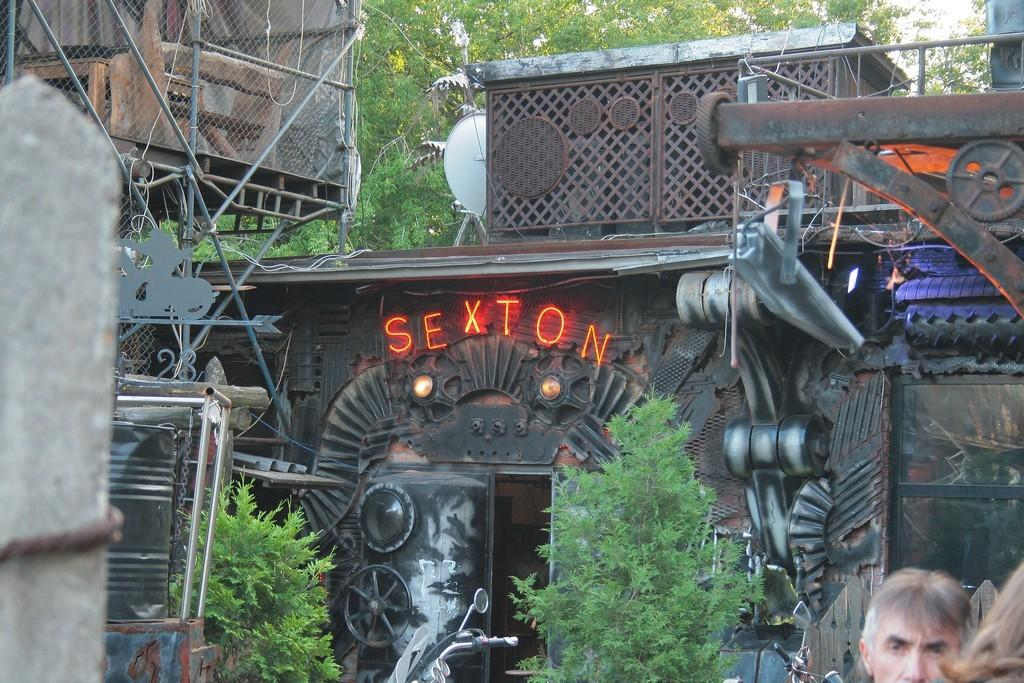What type of structures can be seen in the image? There are buildings in the image. What other elements are present in the image besides buildings? There are plants and trees in the image. Can you describe the people in the image? There are two people on the right side of the image. What type of pump can be seen attached to the donkey in the image? There is no donkey or pump present in the image. 